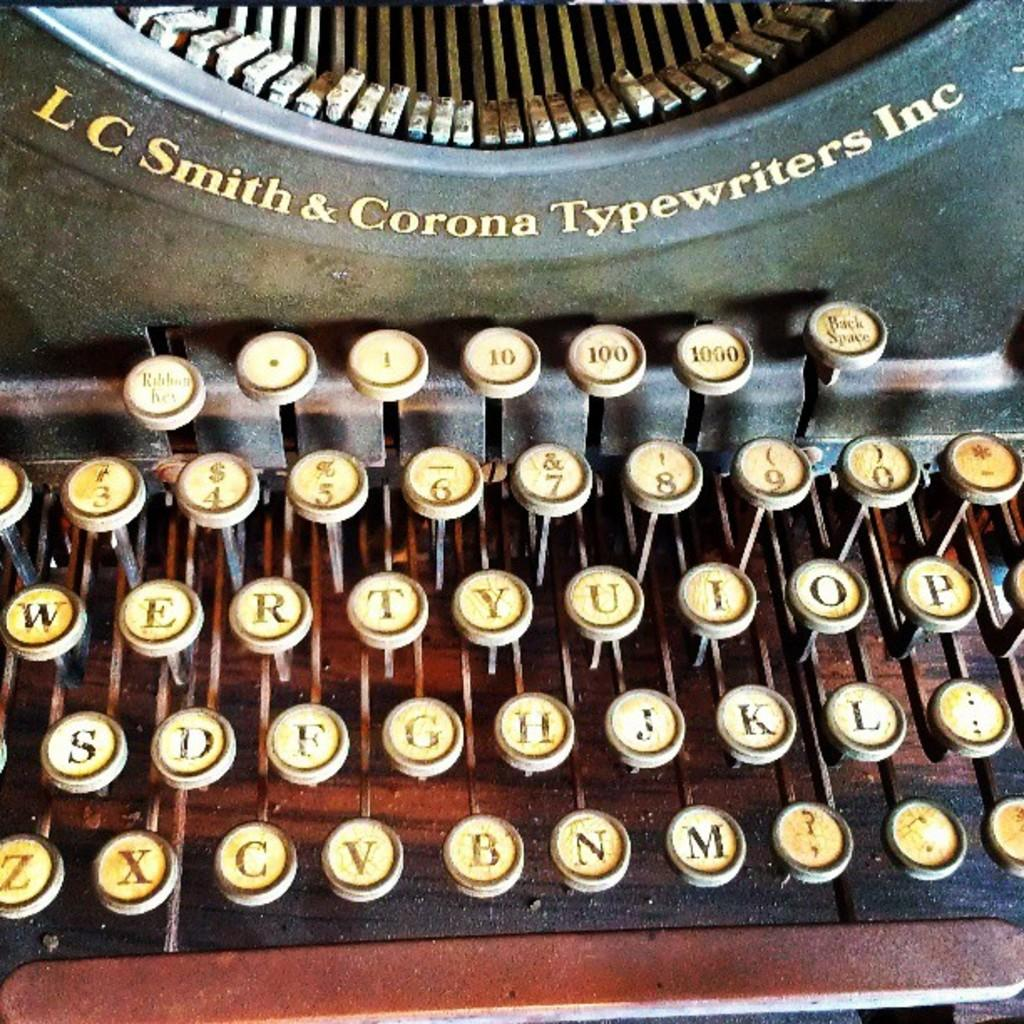<image>
Present a compact description of the photo's key features. an old typewriter made by LC Smith & Corona Typewriters Inc 